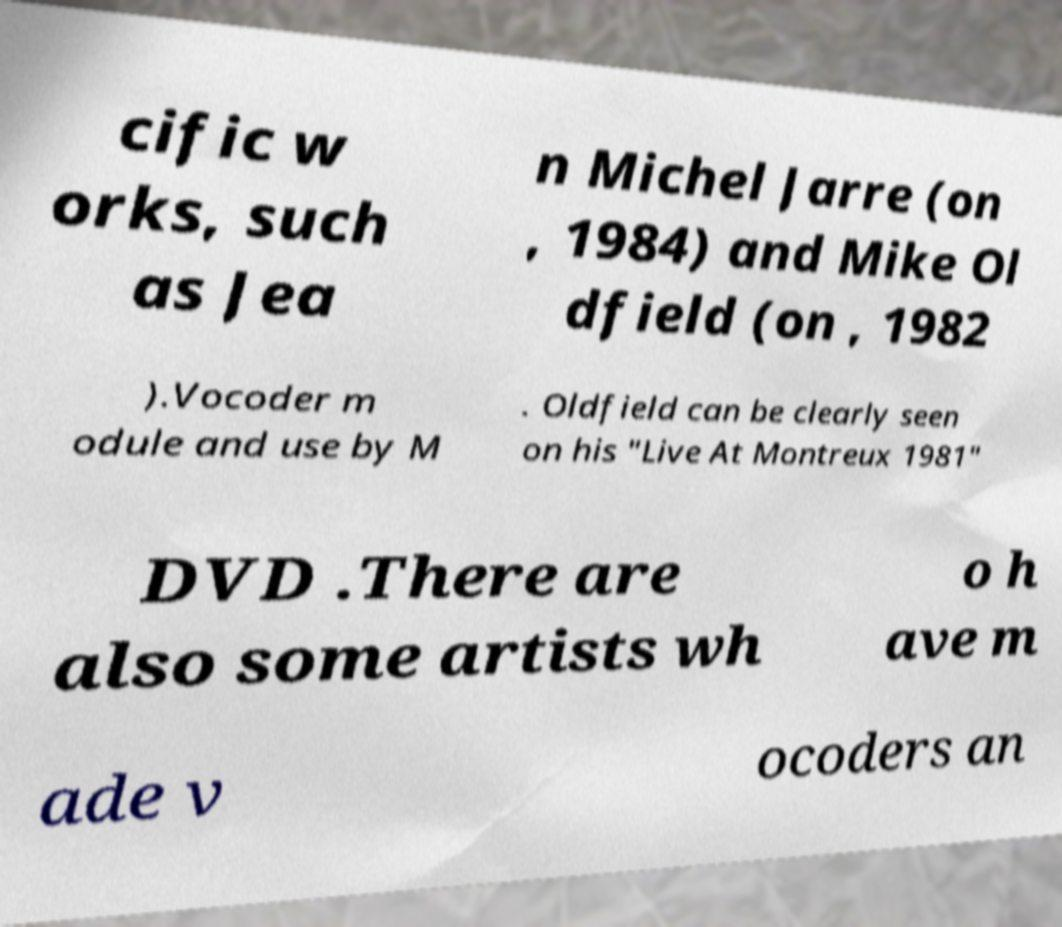What messages or text are displayed in this image? I need them in a readable, typed format. cific w orks, such as Jea n Michel Jarre (on , 1984) and Mike Ol dfield (on , 1982 ).Vocoder m odule and use by M . Oldfield can be clearly seen on his "Live At Montreux 1981" DVD .There are also some artists wh o h ave m ade v ocoders an 